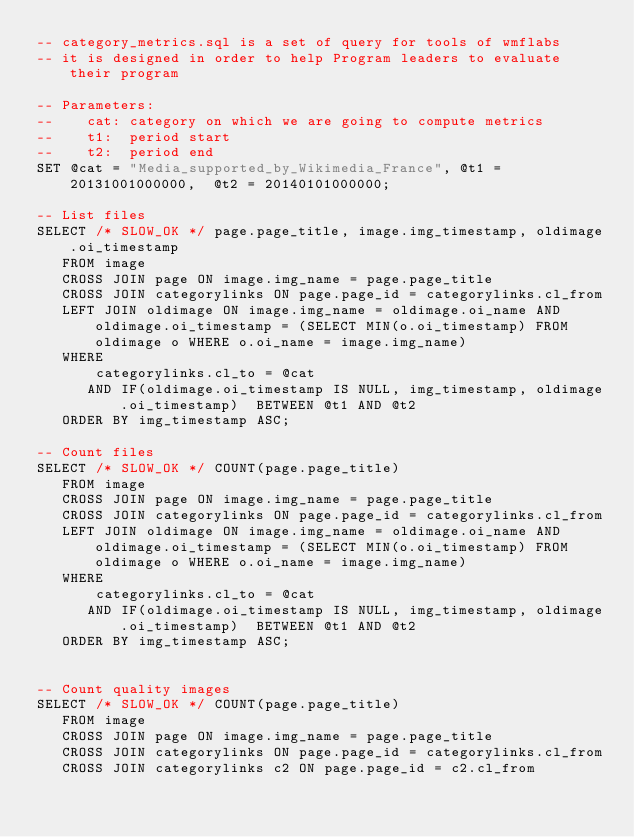Convert code to text. <code><loc_0><loc_0><loc_500><loc_500><_SQL_>-- category_metrics.sql is a set of query for tools of wmflabs
-- it is designed in order to help Program leaders to evaluate their program

-- Parameters:
-- 		cat: category on which we are going to compute metrics
--		t1:  period start
--		t2:  period end
SET @cat = "Media_supported_by_Wikimedia_France", @t1 = 20131001000000,  @t2 = 20140101000000;

-- List files
SELECT /* SLOW_OK */ page.page_title, image.img_timestamp, oldimage.oi_timestamp
   FROM image
   CROSS JOIN page ON image.img_name = page.page_title 
   CROSS JOIN categorylinks ON page.page_id = categorylinks.cl_from
   LEFT JOIN oldimage ON image.img_name = oldimage.oi_name AND oldimage.oi_timestamp = (SELECT MIN(o.oi_timestamp) FROM oldimage o WHERE o.oi_name = image.img_name)
   WHERE  
       categorylinks.cl_to = @cat
      AND IF(oldimage.oi_timestamp IS NULL, img_timestamp, oldimage.oi_timestamp)  BETWEEN @t1 AND @t2
   ORDER BY img_timestamp ASC;

-- Count files
SELECT /* SLOW_OK */ COUNT(page.page_title)
   FROM image
   CROSS JOIN page ON image.img_name = page.page_title 
   CROSS JOIN categorylinks ON page.page_id = categorylinks.cl_from
   LEFT JOIN oldimage ON image.img_name = oldimage.oi_name AND oldimage.oi_timestamp = (SELECT MIN(o.oi_timestamp) FROM oldimage o WHERE o.oi_name = image.img_name)
   WHERE  
       categorylinks.cl_to = @cat
      AND IF(oldimage.oi_timestamp IS NULL, img_timestamp, oldimage.oi_timestamp)  BETWEEN @t1 AND @t2
   ORDER BY img_timestamp ASC;


-- Count quality images
SELECT /* SLOW_OK */ COUNT(page.page_title)
   FROM image
   CROSS JOIN page ON image.img_name = page.page_title 
   CROSS JOIN categorylinks ON page.page_id = categorylinks.cl_from
   CROSS JOIN categorylinks c2 ON page.page_id = c2.cl_from</code> 